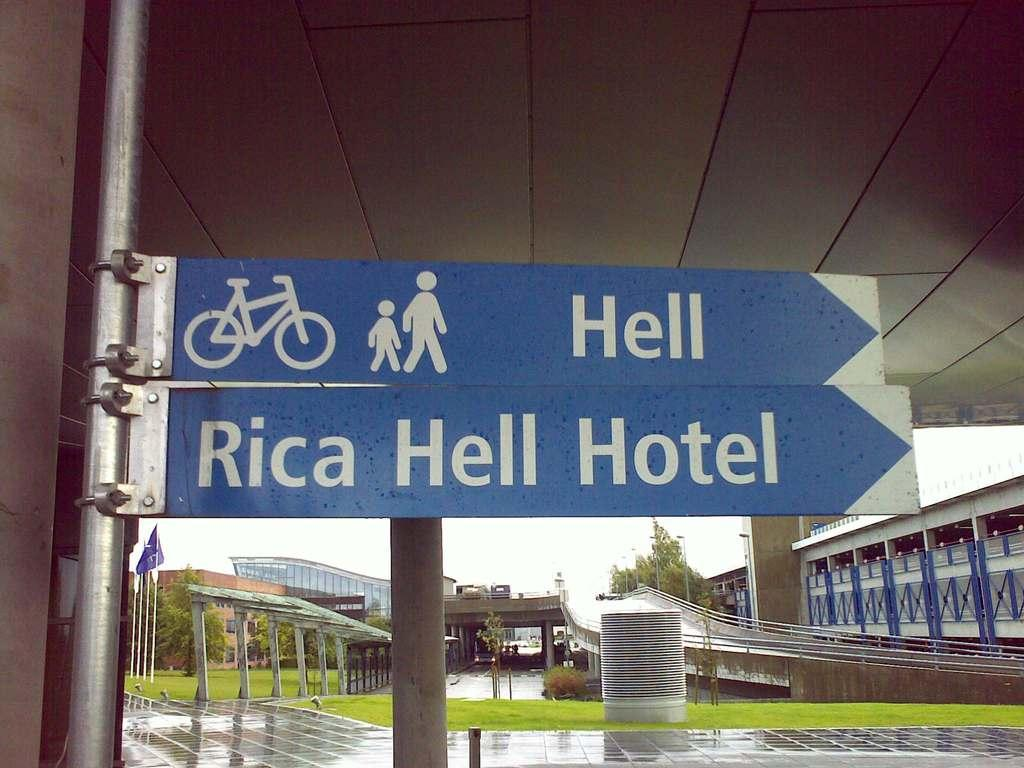What type of objects can be seen in the image that provide information or direction? There are sign boards in the image. What other objects can be seen in the image that are vertical in nature? There are poles in the image. What type of natural vegetation is visible in the image? There is grass visible in the image. What can be seen in the background of the image that represents a country or organization? There are flags in the background of the image. What type of structures can be seen in the background of the image? There are buildings in the background of the image. What type of natural elements can be seen in the background of the image? There are trees in the background of the image. How many twigs are used to fold the flags in the image? There are no twigs present in the image, and the flags are not being folded. What type of comparison can be made between the buildings and the trees in the image? The provided facts do not allow for a comparison between the buildings and the trees in the image. 